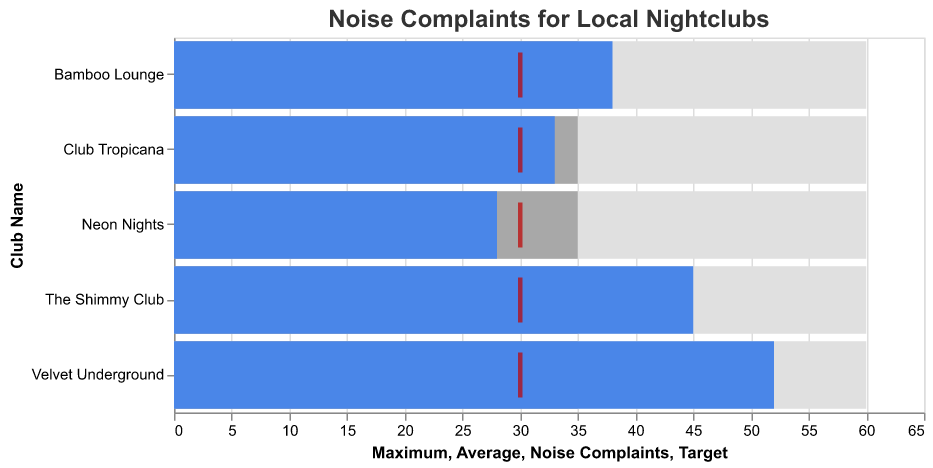What's the title of the chart? The chart title is usually displayed at the top of the figure, which helps to indicate what the chart represents. From the given information, the title states "Noise Complaints for Local Nightclubs".
Answer: Noise Complaints for Local Nightclubs Which nightclub has the highest number of noise complaints? The bar representing the noise complaints is in the darkest color. By visually inspecting the lengths of the bars, we can see that Velvet Underground has the longest bar, indicating the highest number of noise complaints.
Answer: Velvet Underground What is the target number of noise complaints for nightclubs? The target value is represented by a red tick mark in the bullet chart. All clubs have a red tick at the same value on the x-axis. From the provided data, the target value for noise complaints is 30.
Answer: 30 Which nightclub has fewer noise complaints than the target? The nightclubs with fewer complaints than the target should have their blue bar ending before the red tick mark representing the target value. Neon Nights is the only club with noise complaints below 30.
Answer: Neon Nights How many more noise complaints does The Shimmy Club have compared to Bamboo Lounge? To find the difference in noise complaints, subtract the number of complaints for Bamboo Lounge from those for The Shimmy Club (45 - 38). This calculation gives the difference in noise complaints.
Answer: 7 What is the maximum number of noise complaints for any nightclub? The maximum complaints for any nightclub will be the highest value on the maximum range bars. By comparing the heights of the light grey bars, we see the maximum value is 60.
Answer: 60 Which two clubs have the same average number of complaints? The average complaints are represented by the medium color bars. From the given data and the visual inspection of the bars, all clubs have the same average number of complaints, which is 35.
Answer: All clubs What is the difference between the highest and average noise complaints for Velvet Underground? To find this, subtract the average number of complaints from the highest number of complaints for Velvet Underground (52 - 35).
Answer: 17 Which nightclub exceeded the target by the smallest margin? To determine this, find the clubs where the noise complaints exceed the target of 30 and determine which has the smallest difference between its complaints number and 30. Neon Nights is excluded as it did not exceed the target. Club Tropicana has 33 complaints, which exceeds the target by only 3 complaints.
Answer: Club Tropicana How do the noise complaints for The Shimmy Club compare to the average for all nightclubs? We determine the overall average by calculating (45 + 38 + 52 + 28 + 33) / 5 = 39.2. Then compare this with the number of complaints for The Shimmy Club, which has 45 complaints. The Shimmy Club has more complaints than the average for all nightclubs.
Answer: More complaints 